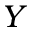<formula> <loc_0><loc_0><loc_500><loc_500>Y</formula> 